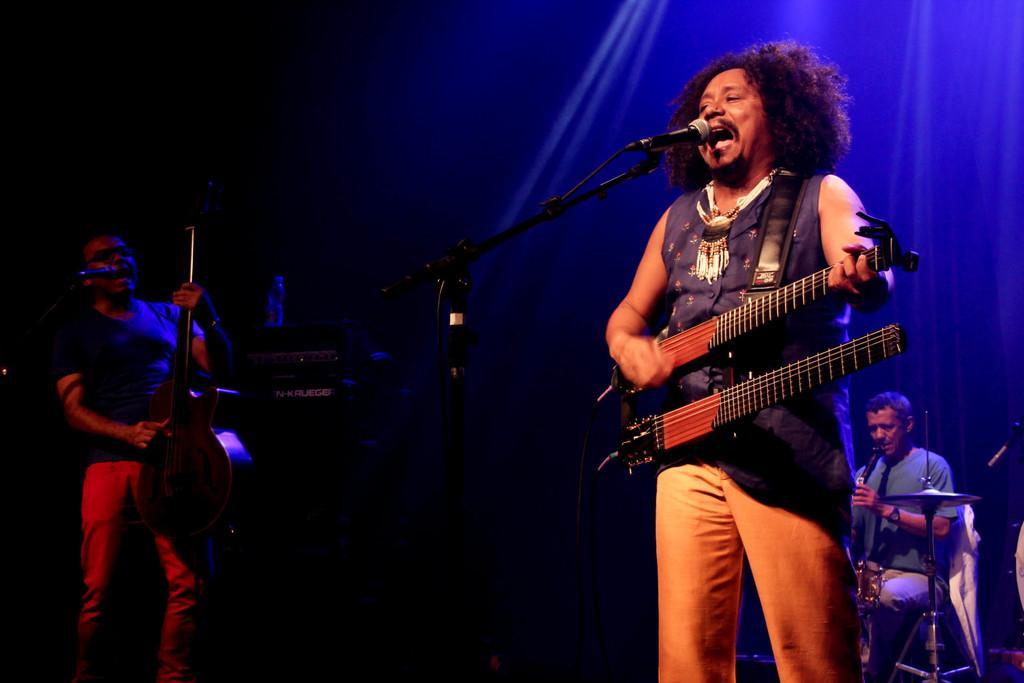Describe this image in one or two sentences. In this picture there are three musicians on the floor. The man in the center and the man at the left corner are singing and playing guitars. There is a microphone in front of them. The man at the right corner is sitting and playing a musical instrument. The background is dark.  